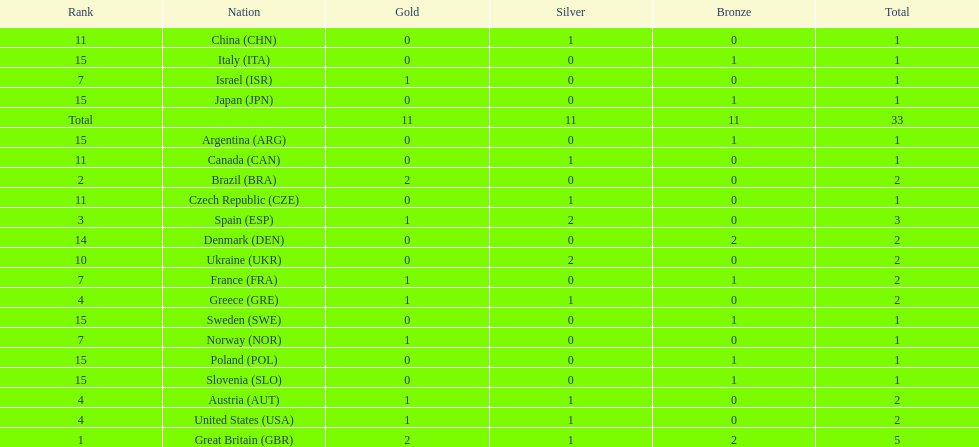Would you mind parsing the complete table? {'header': ['Rank', 'Nation', 'Gold', 'Silver', 'Bronze', 'Total'], 'rows': [['11', 'China\xa0(CHN)', '0', '1', '0', '1'], ['15', 'Italy\xa0(ITA)', '0', '0', '1', '1'], ['7', 'Israel\xa0(ISR)', '1', '0', '0', '1'], ['15', 'Japan\xa0(JPN)', '0', '0', '1', '1'], ['Total', '', '11', '11', '11', '33'], ['15', 'Argentina\xa0(ARG)', '0', '0', '1', '1'], ['11', 'Canada\xa0(CAN)', '0', '1', '0', '1'], ['2', 'Brazil\xa0(BRA)', '2', '0', '0', '2'], ['11', 'Czech Republic\xa0(CZE)', '0', '1', '0', '1'], ['3', 'Spain\xa0(ESP)', '1', '2', '0', '3'], ['14', 'Denmark\xa0(DEN)', '0', '0', '2', '2'], ['10', 'Ukraine\xa0(UKR)', '0', '2', '0', '2'], ['7', 'France\xa0(FRA)', '1', '0', '1', '2'], ['4', 'Greece\xa0(GRE)', '1', '1', '0', '2'], ['15', 'Sweden\xa0(SWE)', '0', '0', '1', '1'], ['7', 'Norway\xa0(NOR)', '1', '0', '0', '1'], ['15', 'Poland\xa0(POL)', '0', '0', '1', '1'], ['15', 'Slovenia\xa0(SLO)', '0', '0', '1', '1'], ['4', 'Austria\xa0(AUT)', '1', '1', '0', '2'], ['4', 'United States\xa0(USA)', '1', '1', '0', '2'], ['1', 'Great Britain\xa0(GBR)', '2', '1', '2', '5']]} How many countries won at least 2 medals in sailing? 9. 